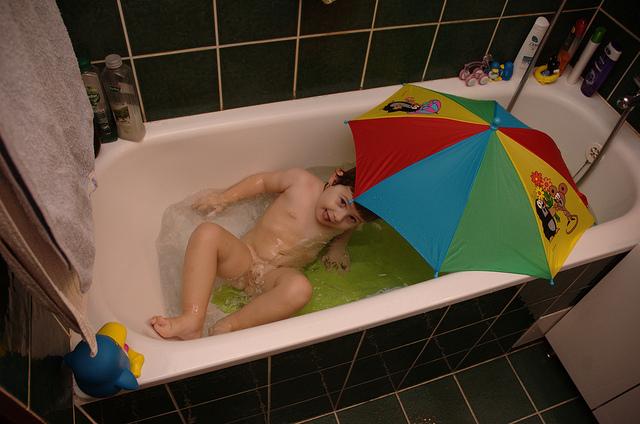How many colors are on the umbrella?
Keep it brief. 4. What color is the tile?
Answer briefly. Black. Did it rain in the bathroom?
Quick response, please. No. 